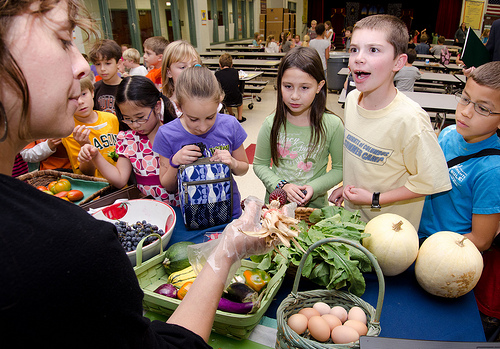<image>
Can you confirm if the table is behind the girl? Yes. From this viewpoint, the table is positioned behind the girl, with the girl partially or fully occluding the table. 